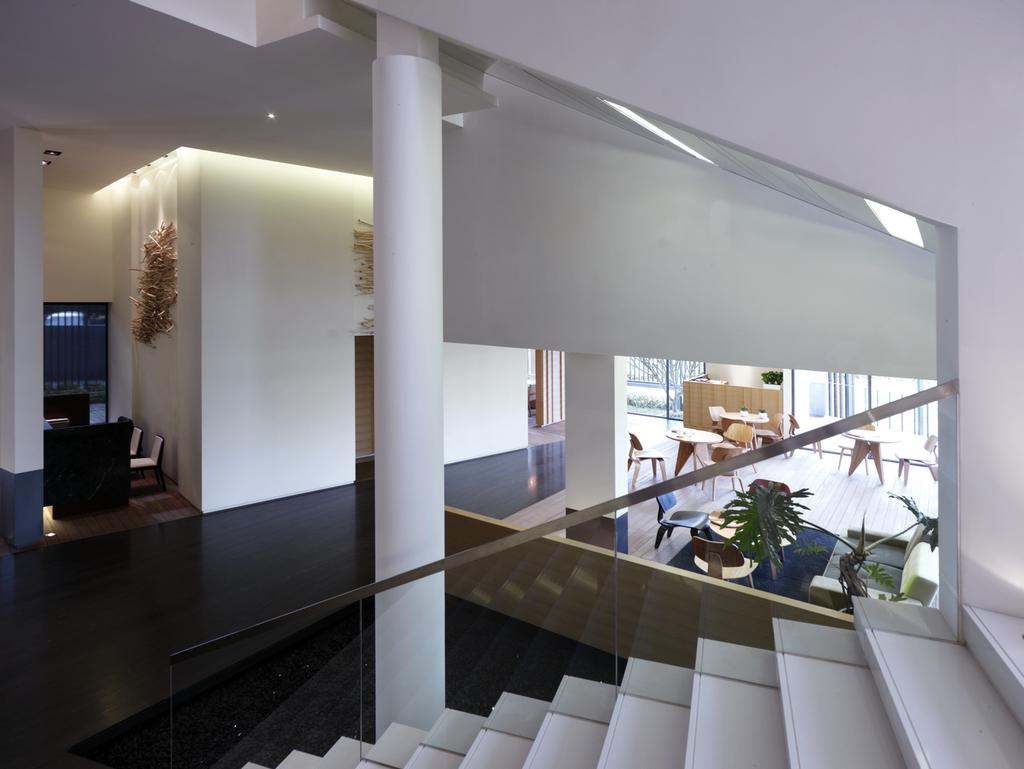What celestial objects can be seen in the image? There are stars visible in the image. What type of architectural feature is present in the image? There is a glass railing in the image. What color is the pillar in the image? There is a white color pillar in the image. What type of furniture is on the right side of the image? There are tables and chairs on the right side of the image. What is visible in the background of the image? There is a wall in the background of the image. How many ants can be seen on the tables and chairs in the image? There are no ants present on the tables and chairs in the image. What type of expression is visible on the wall in the image? There is no expression visible on the wall in the image; it is a stationary architectural feature. 